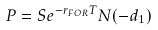Convert formula to latex. <formula><loc_0><loc_0><loc_500><loc_500>P = S e ^ { - r _ { F O R } T } N ( - d _ { 1 } )</formula> 